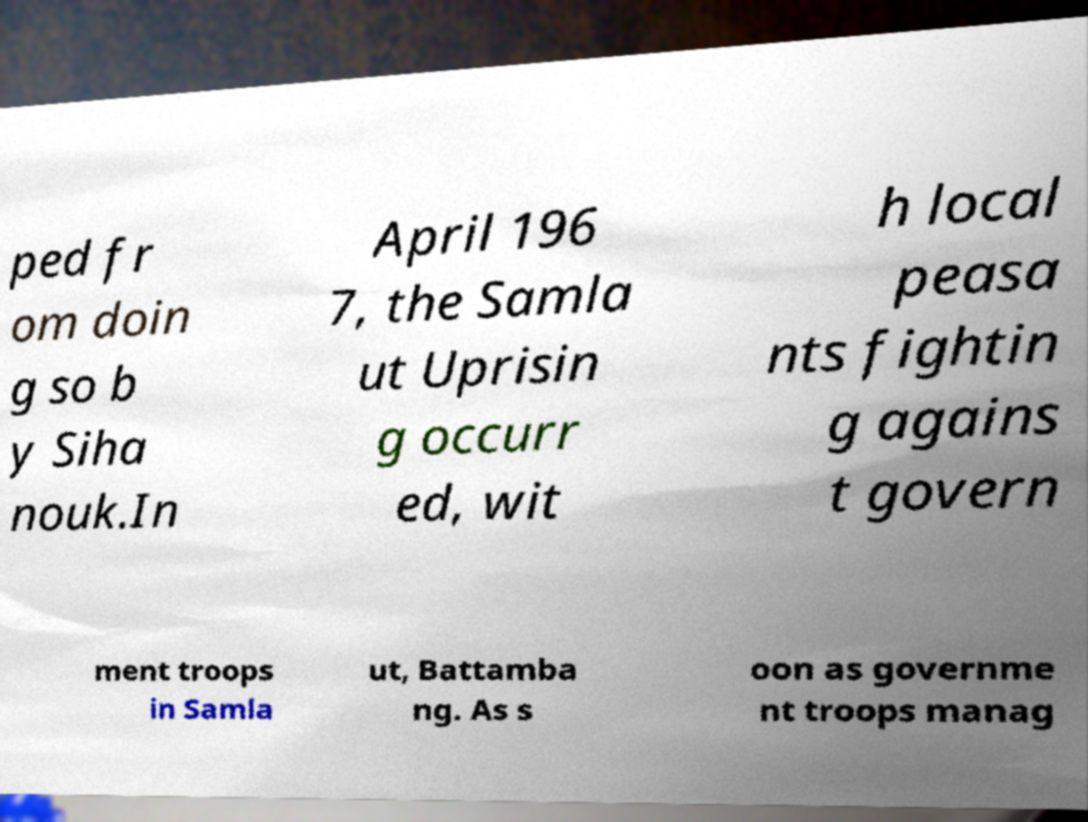Can you read and provide the text displayed in the image?This photo seems to have some interesting text. Can you extract and type it out for me? ped fr om doin g so b y Siha nouk.In April 196 7, the Samla ut Uprisin g occurr ed, wit h local peasa nts fightin g agains t govern ment troops in Samla ut, Battamba ng. As s oon as governme nt troops manag 